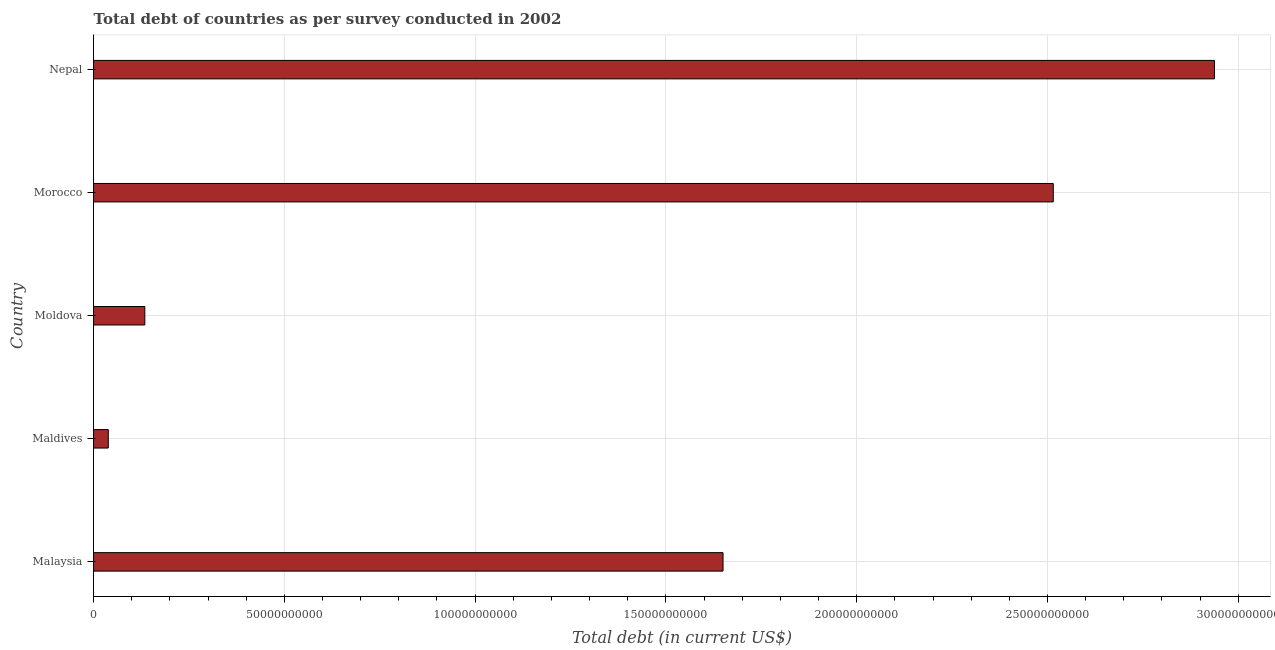What is the title of the graph?
Offer a very short reply. Total debt of countries as per survey conducted in 2002. What is the label or title of the X-axis?
Give a very brief answer. Total debt (in current US$). What is the total debt in Moldova?
Provide a short and direct response. 1.34e+1. Across all countries, what is the maximum total debt?
Your answer should be very brief. 2.94e+11. Across all countries, what is the minimum total debt?
Provide a succinct answer. 3.86e+09. In which country was the total debt maximum?
Your answer should be compact. Nepal. In which country was the total debt minimum?
Your response must be concise. Maldives. What is the sum of the total debt?
Keep it short and to the point. 7.28e+11. What is the difference between the total debt in Malaysia and Morocco?
Give a very brief answer. -8.65e+1. What is the average total debt per country?
Your answer should be very brief. 1.46e+11. What is the median total debt?
Keep it short and to the point. 1.65e+11. What is the ratio of the total debt in Maldives to that in Moldova?
Your answer should be compact. 0.29. Is the total debt in Moldova less than that in Morocco?
Ensure brevity in your answer.  Yes. Is the difference between the total debt in Malaysia and Moldova greater than the difference between any two countries?
Provide a succinct answer. No. What is the difference between the highest and the second highest total debt?
Make the answer very short. 4.22e+1. Is the sum of the total debt in Maldives and Moldova greater than the maximum total debt across all countries?
Your answer should be very brief. No. What is the difference between the highest and the lowest total debt?
Your response must be concise. 2.90e+11. How many bars are there?
Provide a succinct answer. 5. What is the difference between two consecutive major ticks on the X-axis?
Offer a terse response. 5.00e+1. What is the Total debt (in current US$) of Malaysia?
Offer a very short reply. 1.65e+11. What is the Total debt (in current US$) in Maldives?
Your response must be concise. 3.86e+09. What is the Total debt (in current US$) in Moldova?
Provide a succinct answer. 1.34e+1. What is the Total debt (in current US$) of Morocco?
Make the answer very short. 2.52e+11. What is the Total debt (in current US$) of Nepal?
Keep it short and to the point. 2.94e+11. What is the difference between the Total debt (in current US$) in Malaysia and Maldives?
Offer a very short reply. 1.61e+11. What is the difference between the Total debt (in current US$) in Malaysia and Moldova?
Provide a short and direct response. 1.52e+11. What is the difference between the Total debt (in current US$) in Malaysia and Morocco?
Provide a short and direct response. -8.65e+1. What is the difference between the Total debt (in current US$) in Malaysia and Nepal?
Keep it short and to the point. -1.29e+11. What is the difference between the Total debt (in current US$) in Maldives and Moldova?
Offer a terse response. -9.58e+09. What is the difference between the Total debt (in current US$) in Maldives and Morocco?
Make the answer very short. -2.48e+11. What is the difference between the Total debt (in current US$) in Maldives and Nepal?
Your answer should be compact. -2.90e+11. What is the difference between the Total debt (in current US$) in Moldova and Morocco?
Give a very brief answer. -2.38e+11. What is the difference between the Total debt (in current US$) in Moldova and Nepal?
Keep it short and to the point. -2.80e+11. What is the difference between the Total debt (in current US$) in Morocco and Nepal?
Provide a short and direct response. -4.22e+1. What is the ratio of the Total debt (in current US$) in Malaysia to that in Maldives?
Your response must be concise. 42.77. What is the ratio of the Total debt (in current US$) in Malaysia to that in Moldova?
Ensure brevity in your answer.  12.28. What is the ratio of the Total debt (in current US$) in Malaysia to that in Morocco?
Ensure brevity in your answer.  0.66. What is the ratio of the Total debt (in current US$) in Malaysia to that in Nepal?
Offer a terse response. 0.56. What is the ratio of the Total debt (in current US$) in Maldives to that in Moldova?
Provide a succinct answer. 0.29. What is the ratio of the Total debt (in current US$) in Maldives to that in Morocco?
Provide a short and direct response. 0.01. What is the ratio of the Total debt (in current US$) in Maldives to that in Nepal?
Your response must be concise. 0.01. What is the ratio of the Total debt (in current US$) in Moldova to that in Morocco?
Offer a terse response. 0.05. What is the ratio of the Total debt (in current US$) in Moldova to that in Nepal?
Ensure brevity in your answer.  0.05. What is the ratio of the Total debt (in current US$) in Morocco to that in Nepal?
Your answer should be very brief. 0.86. 